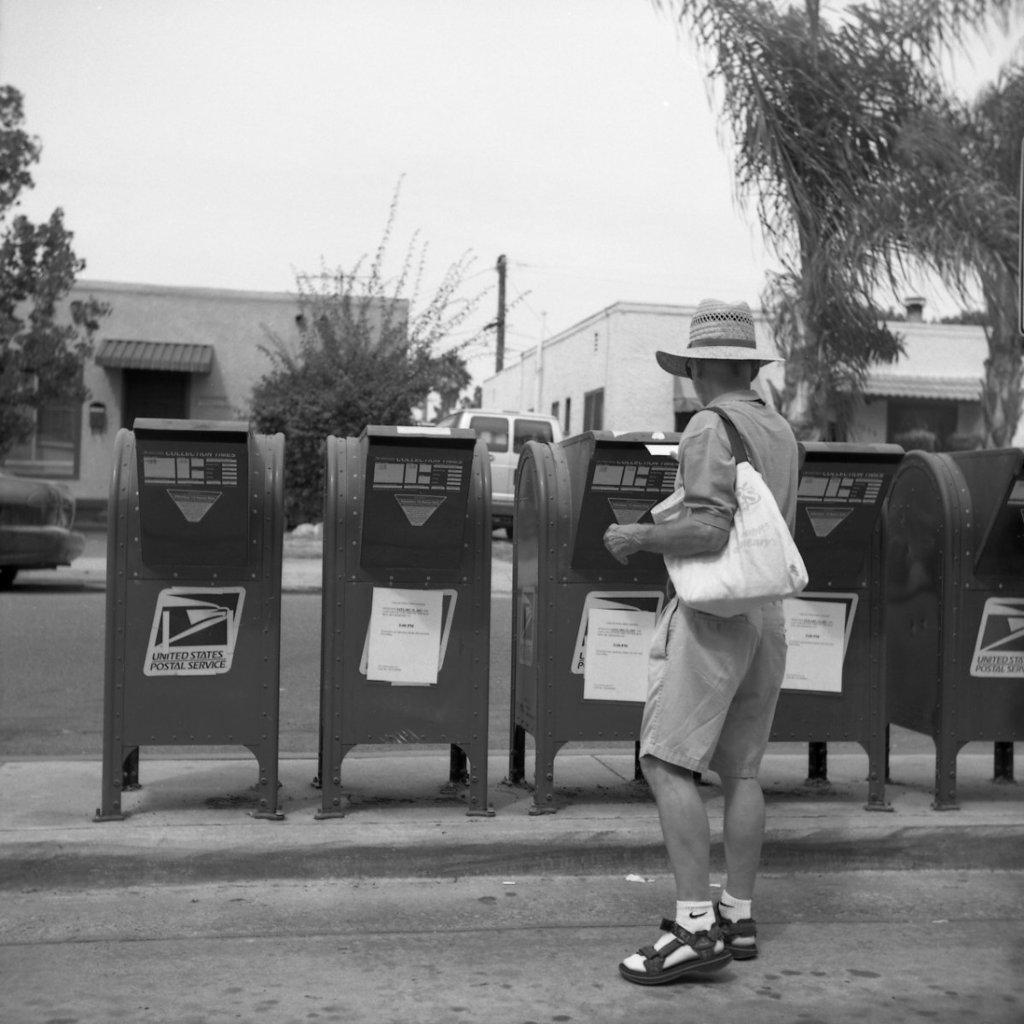<image>
Relay a brief, clear account of the picture shown. A man is looking at a row of mailboxes, which are serviced by the United States Postal Service. 